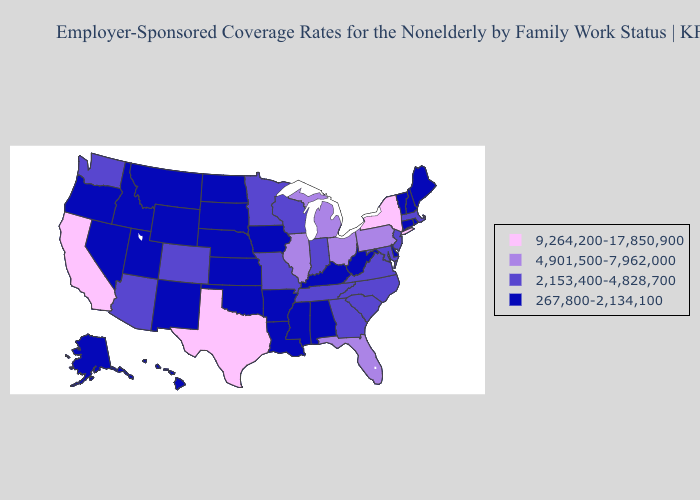Name the states that have a value in the range 4,901,500-7,962,000?
Answer briefly. Florida, Illinois, Michigan, Ohio, Pennsylvania. Name the states that have a value in the range 4,901,500-7,962,000?
Concise answer only. Florida, Illinois, Michigan, Ohio, Pennsylvania. Does Indiana have the highest value in the USA?
Keep it brief. No. Does the map have missing data?
Concise answer only. No. What is the lowest value in the USA?
Write a very short answer. 267,800-2,134,100. Name the states that have a value in the range 267,800-2,134,100?
Write a very short answer. Alabama, Alaska, Arkansas, Connecticut, Delaware, Hawaii, Idaho, Iowa, Kansas, Kentucky, Louisiana, Maine, Mississippi, Montana, Nebraska, Nevada, New Hampshire, New Mexico, North Dakota, Oklahoma, Oregon, Rhode Island, South Dakota, Utah, Vermont, West Virginia, Wyoming. What is the value of Hawaii?
Quick response, please. 267,800-2,134,100. Does the map have missing data?
Be succinct. No. Name the states that have a value in the range 4,901,500-7,962,000?
Quick response, please. Florida, Illinois, Michigan, Ohio, Pennsylvania. What is the value of Arizona?
Give a very brief answer. 2,153,400-4,828,700. What is the highest value in the MidWest ?
Short answer required. 4,901,500-7,962,000. Name the states that have a value in the range 2,153,400-4,828,700?
Keep it brief. Arizona, Colorado, Georgia, Indiana, Maryland, Massachusetts, Minnesota, Missouri, New Jersey, North Carolina, South Carolina, Tennessee, Virginia, Washington, Wisconsin. Name the states that have a value in the range 9,264,200-17,850,900?
Keep it brief. California, New York, Texas. What is the lowest value in the USA?
Keep it brief. 267,800-2,134,100. What is the lowest value in the West?
Give a very brief answer. 267,800-2,134,100. 